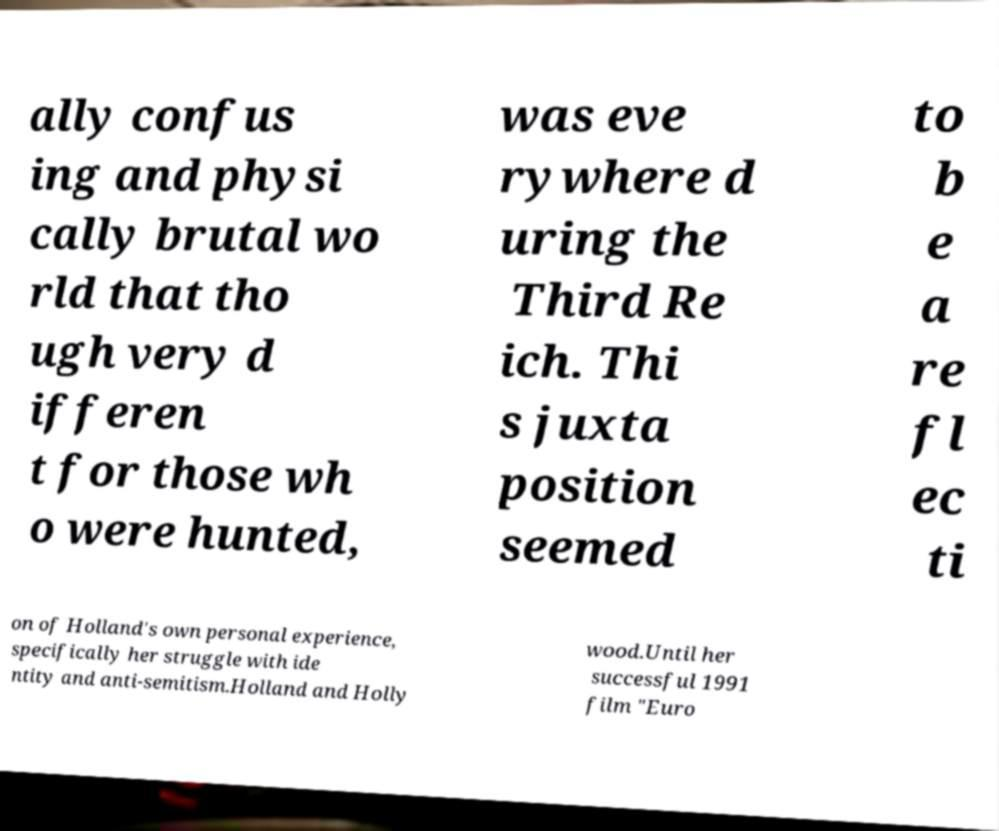There's text embedded in this image that I need extracted. Can you transcribe it verbatim? ally confus ing and physi cally brutal wo rld that tho ugh very d ifferen t for those wh o were hunted, was eve rywhere d uring the Third Re ich. Thi s juxta position seemed to b e a re fl ec ti on of Holland's own personal experience, specifically her struggle with ide ntity and anti-semitism.Holland and Holly wood.Until her successful 1991 film "Euro 